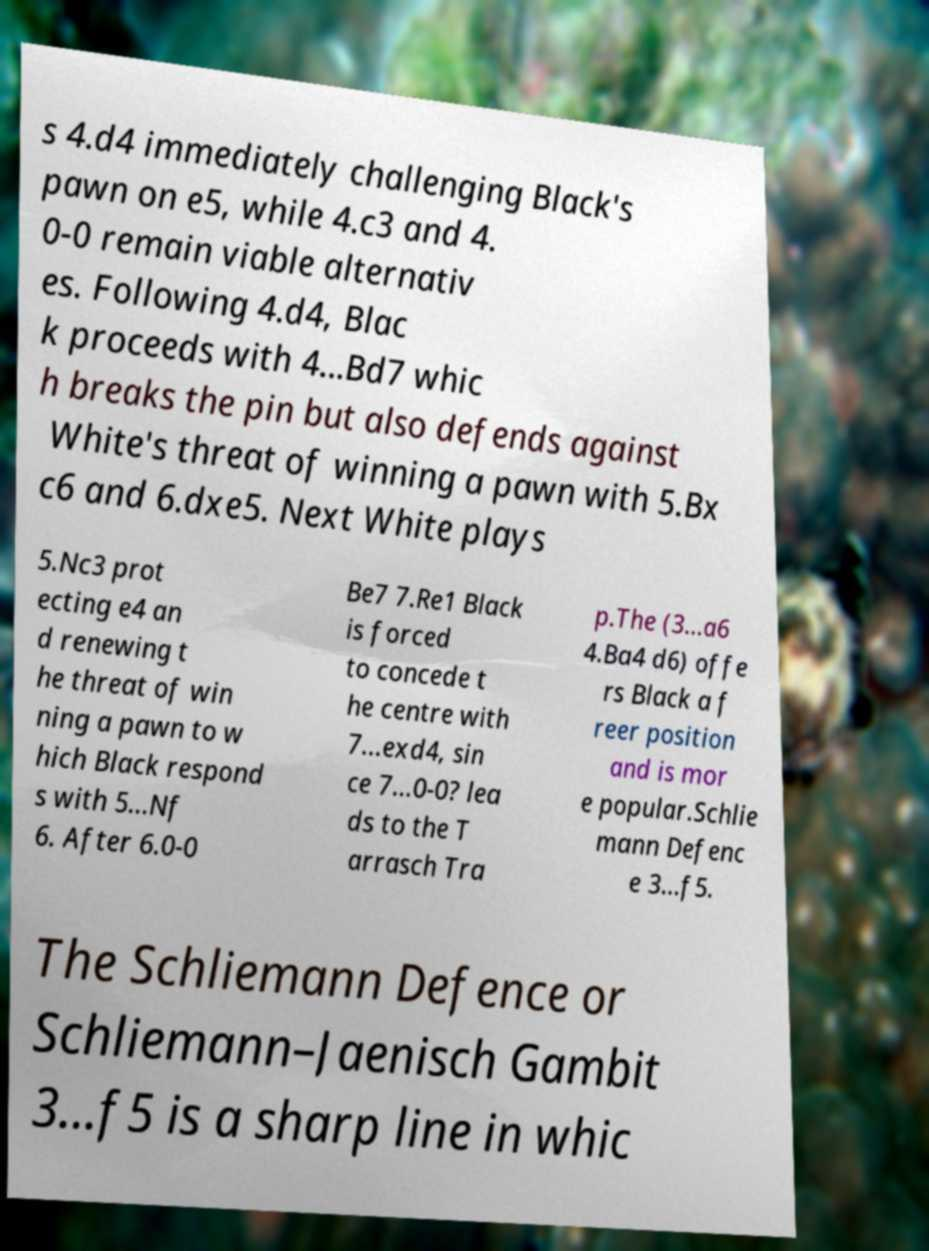Could you assist in decoding the text presented in this image and type it out clearly? s 4.d4 immediately challenging Black's pawn on e5, while 4.c3 and 4. 0-0 remain viable alternativ es. Following 4.d4, Blac k proceeds with 4...Bd7 whic h breaks the pin but also defends against White's threat of winning a pawn with 5.Bx c6 and 6.dxe5. Next White plays 5.Nc3 prot ecting e4 an d renewing t he threat of win ning a pawn to w hich Black respond s with 5...Nf 6. After 6.0-0 Be7 7.Re1 Black is forced to concede t he centre with 7...exd4, sin ce 7...0-0? lea ds to the T arrasch Tra p.The (3...a6 4.Ba4 d6) offe rs Black a f reer position and is mor e popular.Schlie mann Defenc e 3...f5. The Schliemann Defence or Schliemann–Jaenisch Gambit 3...f5 is a sharp line in whic 